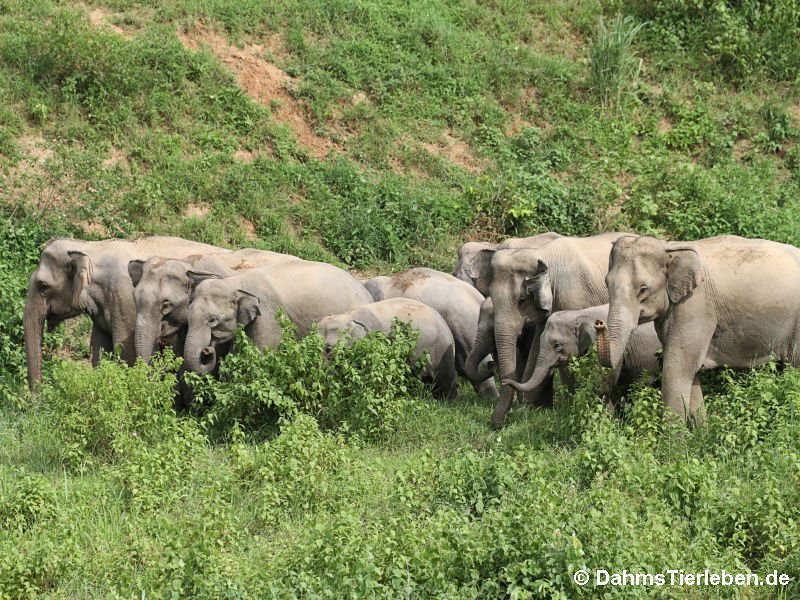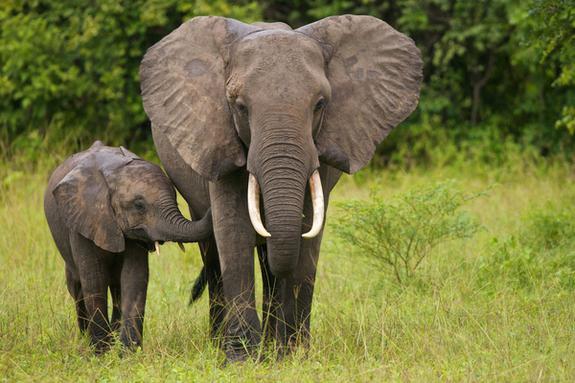The first image is the image on the left, the second image is the image on the right. Analyze the images presented: Is the assertion "An image shows one or more adult elephants with trunk raised at least head-high." valid? Answer yes or no. No. 